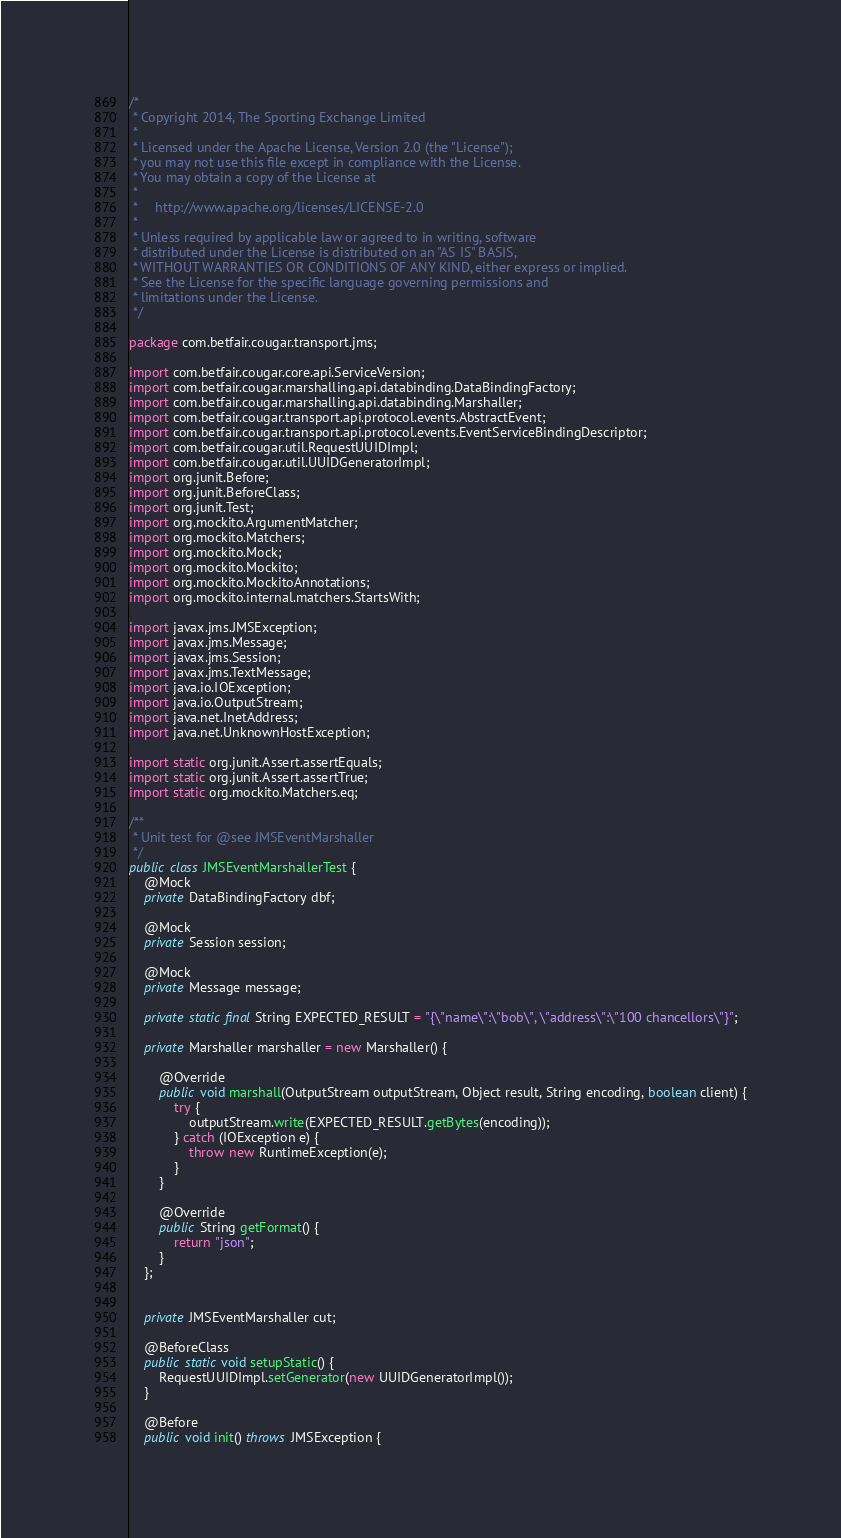<code> <loc_0><loc_0><loc_500><loc_500><_Java_>/*
 * Copyright 2014, The Sporting Exchange Limited
 *
 * Licensed under the Apache License, Version 2.0 (the "License");
 * you may not use this file except in compliance with the License.
 * You may obtain a copy of the License at
 *
 *     http://www.apache.org/licenses/LICENSE-2.0
 *
 * Unless required by applicable law or agreed to in writing, software
 * distributed under the License is distributed on an "AS IS" BASIS,
 * WITHOUT WARRANTIES OR CONDITIONS OF ANY KIND, either express or implied.
 * See the License for the specific language governing permissions and
 * limitations under the License.
 */

package com.betfair.cougar.transport.jms;

import com.betfair.cougar.core.api.ServiceVersion;
import com.betfair.cougar.marshalling.api.databinding.DataBindingFactory;
import com.betfair.cougar.marshalling.api.databinding.Marshaller;
import com.betfair.cougar.transport.api.protocol.events.AbstractEvent;
import com.betfair.cougar.transport.api.protocol.events.EventServiceBindingDescriptor;
import com.betfair.cougar.util.RequestUUIDImpl;
import com.betfair.cougar.util.UUIDGeneratorImpl;
import org.junit.Before;
import org.junit.BeforeClass;
import org.junit.Test;
import org.mockito.ArgumentMatcher;
import org.mockito.Matchers;
import org.mockito.Mock;
import org.mockito.Mockito;
import org.mockito.MockitoAnnotations;
import org.mockito.internal.matchers.StartsWith;

import javax.jms.JMSException;
import javax.jms.Message;
import javax.jms.Session;
import javax.jms.TextMessage;
import java.io.IOException;
import java.io.OutputStream;
import java.net.InetAddress;
import java.net.UnknownHostException;

import static org.junit.Assert.assertEquals;
import static org.junit.Assert.assertTrue;
import static org.mockito.Matchers.eq;

/**
 * Unit test for @see JMSEventMarshaller
 */
public class JMSEventMarshallerTest {
    @Mock
    private DataBindingFactory dbf;

    @Mock
    private Session session;

    @Mock
    private Message message;

    private static final String EXPECTED_RESULT = "{\"name\":\"bob\", \"address\":\"100 chancellors\"}";

    private Marshaller marshaller = new Marshaller() {

        @Override
        public void marshall(OutputStream outputStream, Object result, String encoding, boolean client) {
            try {
                outputStream.write(EXPECTED_RESULT.getBytes(encoding));
            } catch (IOException e) {
                throw new RuntimeException(e);
            }
        }

        @Override
        public String getFormat() {
            return "json";
        }
    };


    private JMSEventMarshaller cut;

    @BeforeClass
    public static void setupStatic() {
        RequestUUIDImpl.setGenerator(new UUIDGeneratorImpl());
    }

    @Before
    public void init() throws JMSException {</code> 